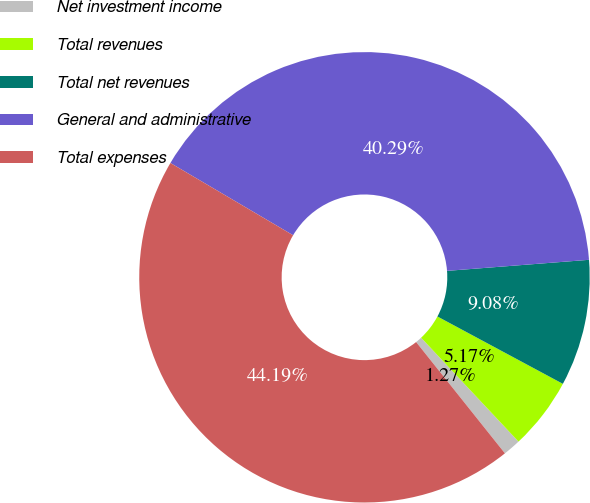<chart> <loc_0><loc_0><loc_500><loc_500><pie_chart><fcel>Net investment income<fcel>Total revenues<fcel>Total net revenues<fcel>General and administrative<fcel>Total expenses<nl><fcel>1.27%<fcel>5.17%<fcel>9.08%<fcel>40.29%<fcel>44.19%<nl></chart> 